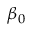Convert formula to latex. <formula><loc_0><loc_0><loc_500><loc_500>\beta _ { 0 }</formula> 